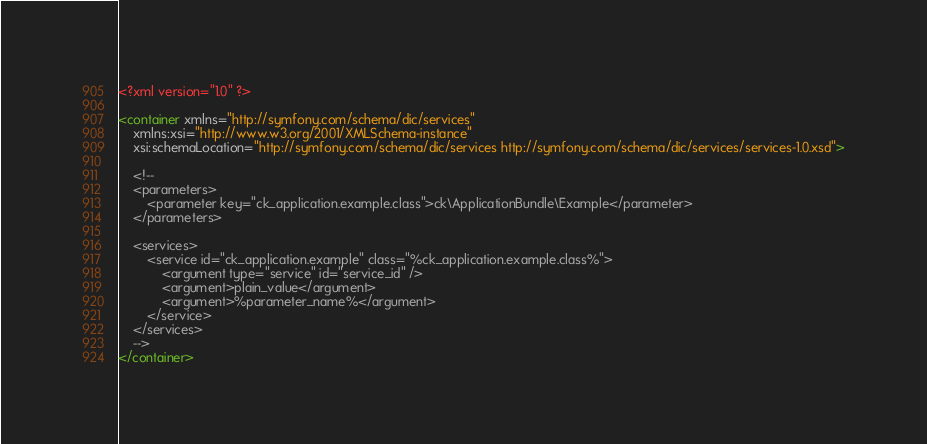Convert code to text. <code><loc_0><loc_0><loc_500><loc_500><_XML_><?xml version="1.0" ?>

<container xmlns="http://symfony.com/schema/dic/services"
    xmlns:xsi="http://www.w3.org/2001/XMLSchema-instance"
    xsi:schemaLocation="http://symfony.com/schema/dic/services http://symfony.com/schema/dic/services/services-1.0.xsd">

    <!--
    <parameters>
        <parameter key="ck_application.example.class">ck\ApplicationBundle\Example</parameter>
    </parameters>

    <services>
        <service id="ck_application.example" class="%ck_application.example.class%">
            <argument type="service" id="service_id" />
            <argument>plain_value</argument>
            <argument>%parameter_name%</argument>
        </service>
    </services>
    -->
</container>
</code> 